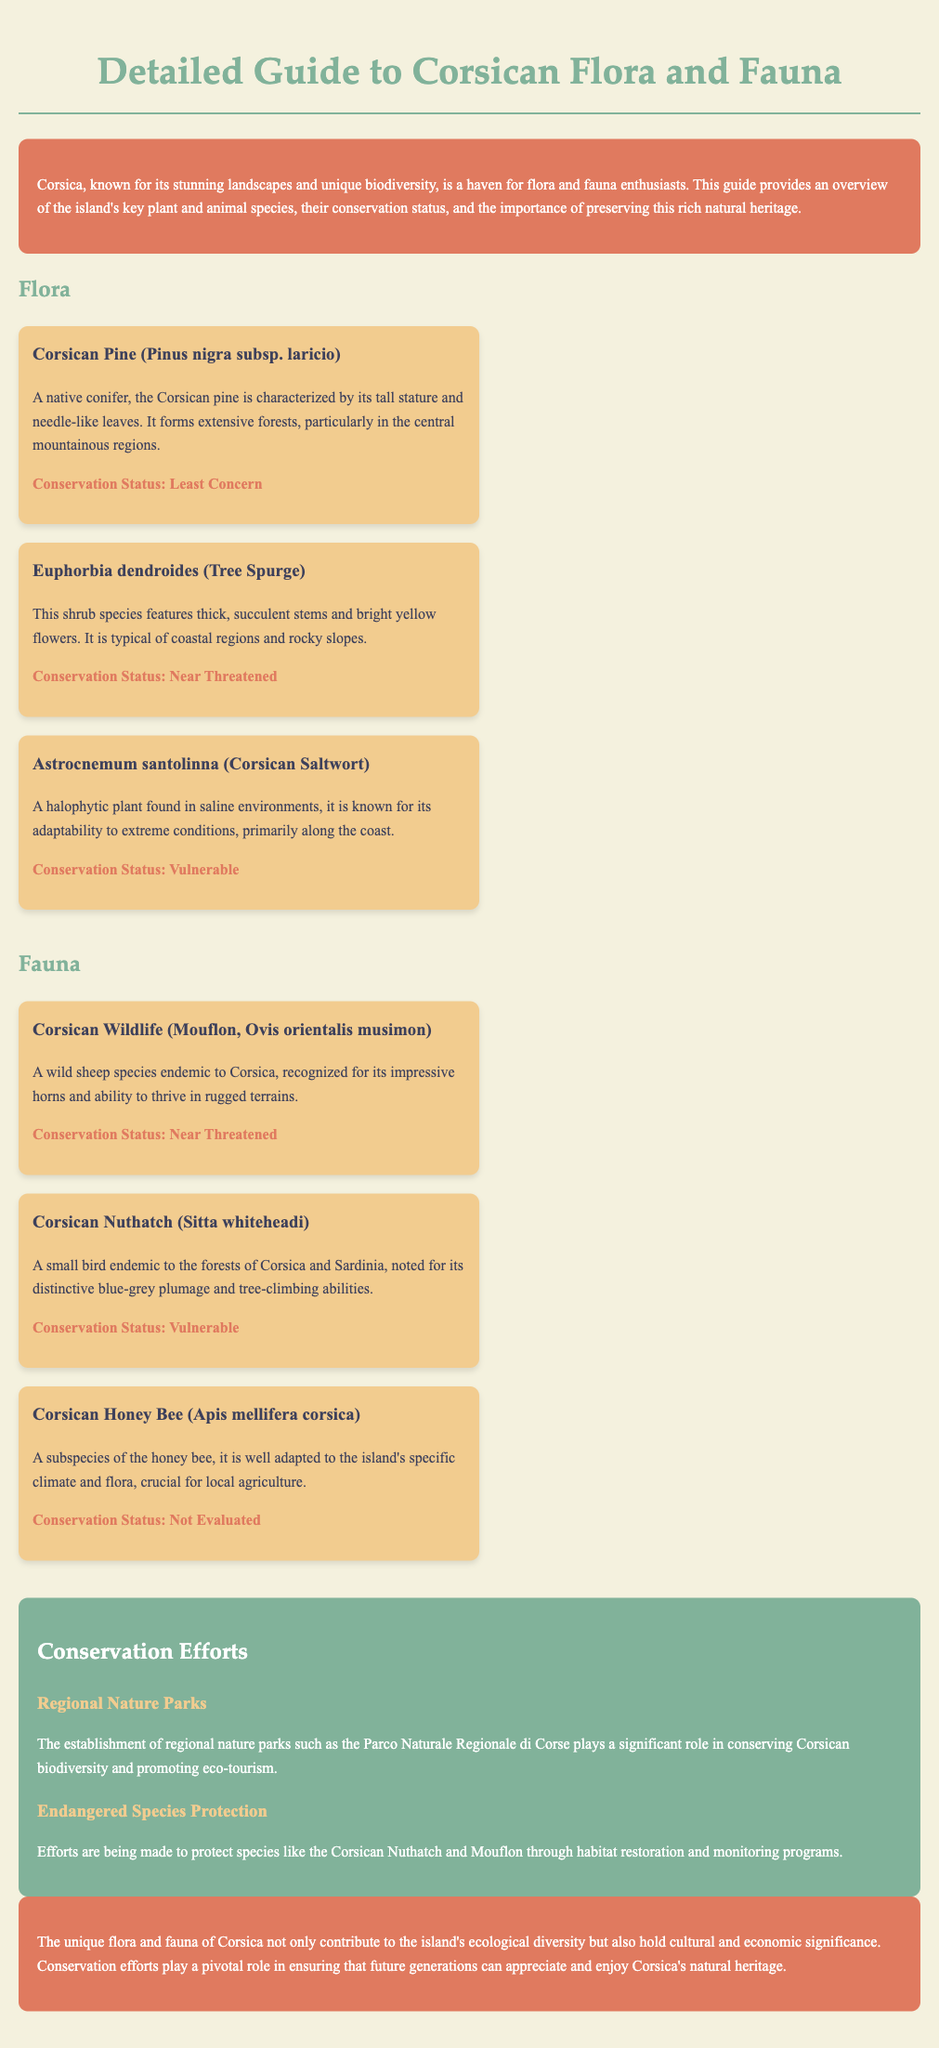what is the conservation status of Corsican Pine? The conservation status of Corsican Pine is listed under the flora section of the document, highlighting it as "Least Concern."
Answer: Least Concern which endemic bird species is mentioned in the document? The document identifies the Corsican Nuthatch as a bird species endemic to the forests of Corsica and Sardinia.
Answer: Corsican Nuthatch how many species are listed under the fauna section? The fauna section contains three species of wildlife mentioned in the document.
Answer: 3 what type of plant is Euphorbia dendroides? Euphorbia dendroides is identified in the document as a shrub species that is common in coastal regions.
Answer: Shrub what is the primary conservation effort mentioned for endangered species? The primary conservation effort involves habitat restoration and monitoring programs aimed at protecting endangered species in Corsica.
Answer: Habitat restoration and monitoring programs what is the title of the guide? The title is prominently displayed at the top of the document, identifying the guide as "Detailed Guide to Corsican Flora and Fauna."
Answer: Detailed Guide to Corsican Flora and Fauna what color is the introduction section's background? The introduction section's background is described as having a specific color mentioned in the document, which is a shade of red-orange.
Answer: Red-orange which animal species is recognized for its impressive horns? The document describes the Mouflon as the animal species known for its impressive horns and ability to thrive in rugged terrains.
Answer: Mouflon 